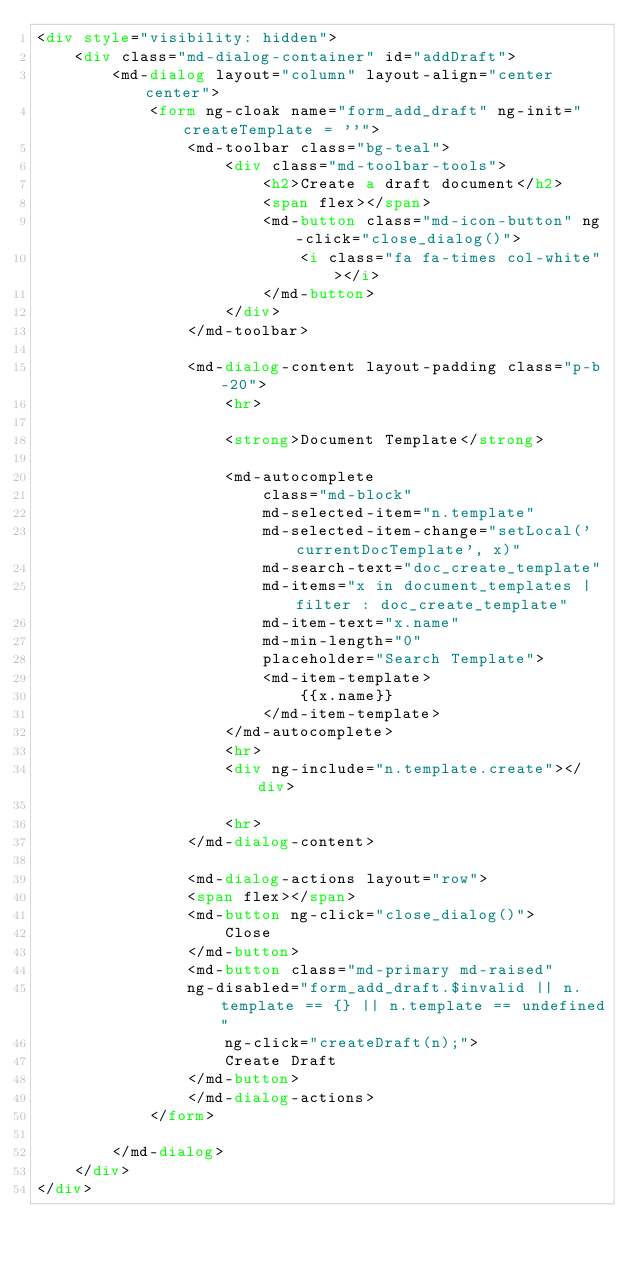Convert code to text. <code><loc_0><loc_0><loc_500><loc_500><_HTML_><div style="visibility: hidden">
    <div class="md-dialog-container" id="addDraft">
        <md-dialog layout="column" layout-align="center center">
            <form ng-cloak name="form_add_draft" ng-init="createTemplate = ''">
                <md-toolbar class="bg-teal">
                    <div class="md-toolbar-tools">
                        <h2>Create a draft document</h2>
                        <span flex></span>
                        <md-button class="md-icon-button" ng-click="close_dialog()">
                            <i class="fa fa-times col-white"></i>
                        </md-button>
                    </div>
                </md-toolbar>
                
                <md-dialog-content layout-padding class="p-b-20">
                    <hr>

                    <strong>Document Template</strong>

                    <md-autocomplete
                        class="md-block" 
                        md-selected-item="n.template"
                        md-selected-item-change="setLocal('currentDocTemplate', x)"
                        md-search-text="doc_create_template"
                        md-items="x in document_templates | filter : doc_create_template"
                        md-item-text="x.name"
                        md-min-length="0"
                        placeholder="Search Template">
                        <md-item-template>
                            {{x.name}}
                        </md-item-template>
                    </md-autocomplete>
                    <hr>
                    <div ng-include="n.template.create"></div>

                    <hr>
                </md-dialog-content>
            
                <md-dialog-actions layout="row">
                <span flex></span>
                <md-button ng-click="close_dialog()">
                    Close
                </md-button>
                <md-button class="md-primary md-raised" 
                ng-disabled="form_add_draft.$invalid || n.template == {} || n.template == undefined" 
                    ng-click="createDraft(n);">
                    Create Draft
                </md-button>
                </md-dialog-actions>
            </form>

        </md-dialog>
    </div>
</div></code> 